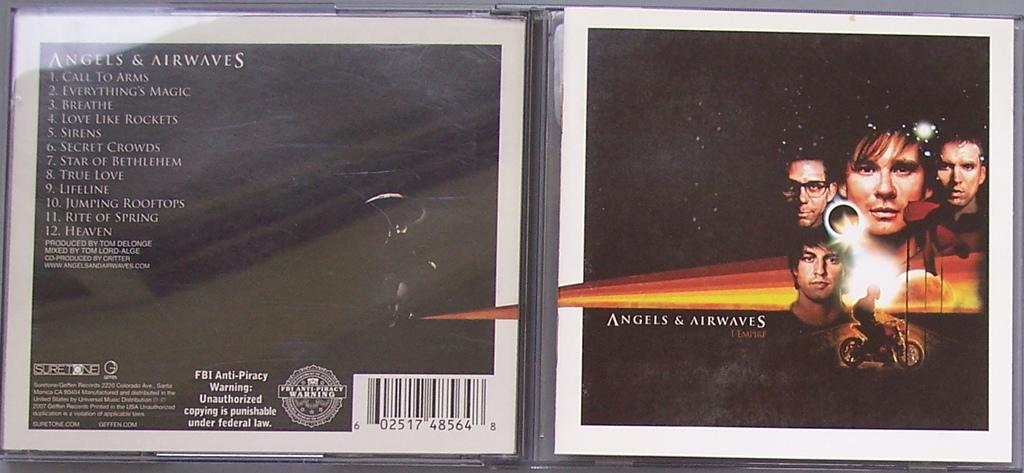<image>
Offer a succinct explanation of the picture presented. A cd case is open and is titled Angels and Airwaves. 